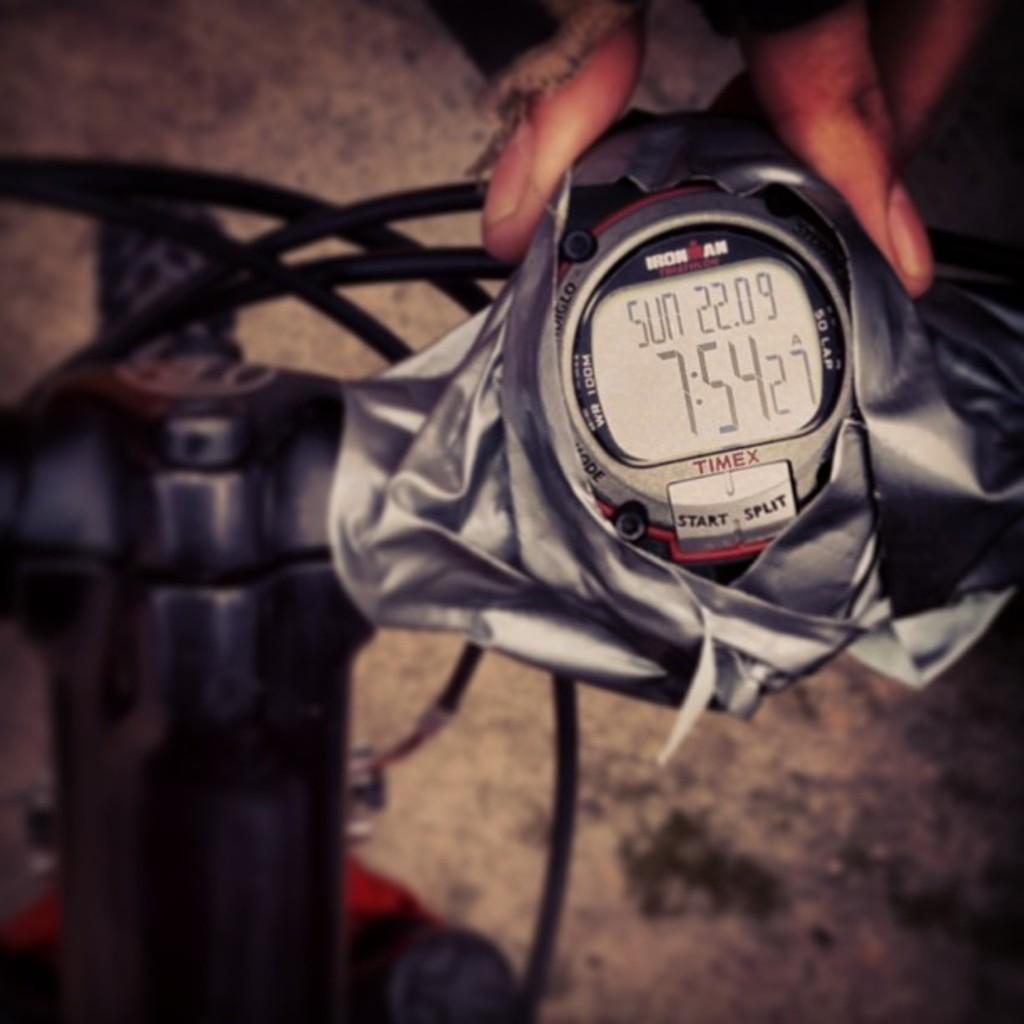What body part is visible in the image? The image contains the fingers of a person. What accessory is visible on the fingers? There is a watch visible in the image. What information can be gathered from the watch? The watch has text and time displayed on it. What can be seen on the left side of the image? There is a black object on the left side of the image. How many snails are crawling on the watch in the image? There are no snails present in the image; it only features the fingers of a person and a watch. What type of kite is being flown by the person in the image? There is no kite present in the image; it only features the fingers of a person and a watch. 